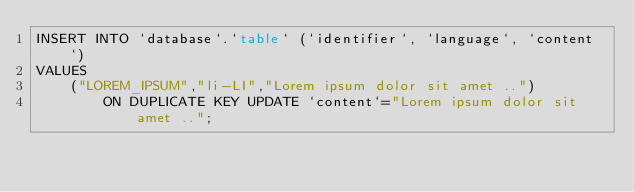<code> <loc_0><loc_0><loc_500><loc_500><_SQL_>INSERT INTO `database`.`table` (`identifier`, `language`, `content`)
VALUES
    ("LOREM_IPSUM","li-LI","Lorem ipsum dolor sit amet ..")
        ON DUPLICATE KEY UPDATE `content`="Lorem ipsum dolor sit amet ..";</code> 